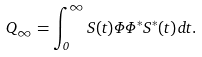Convert formula to latex. <formula><loc_0><loc_0><loc_500><loc_500>Q _ { \infty } = \int _ { 0 } ^ { \infty } S ( t ) \Phi \Phi ^ { * } S ^ { * } ( t ) \, d t .</formula> 